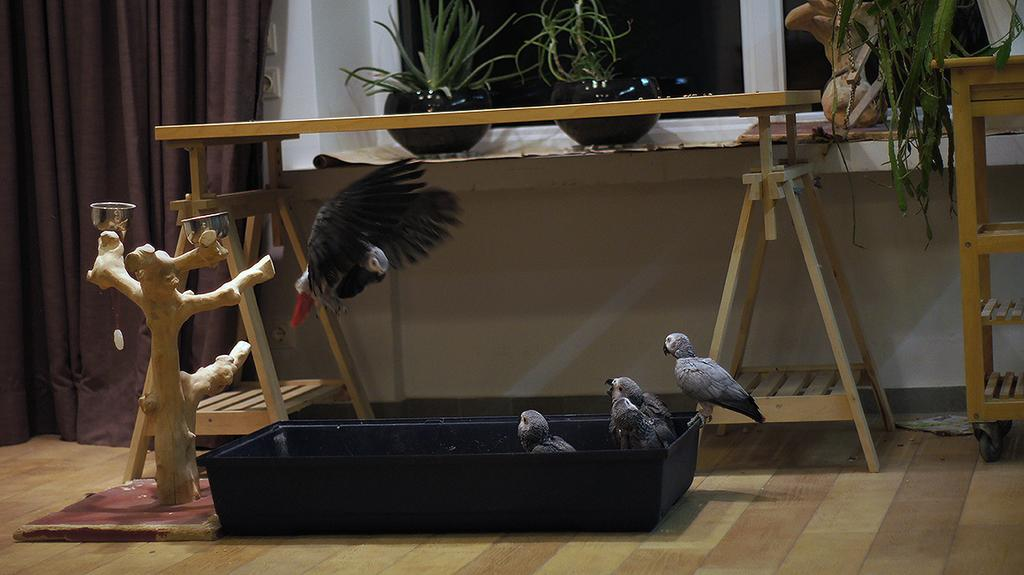What is the main subject of the image? The main subject of the image is a depiction of a tree trunk. What objects are present in the image besides the tree trunk? There are bowls, a black-colored object, birds, tables, plants, and a brown-colored curtain in the image. Can you describe the black-colored object in the image? Unfortunately, the facts provided do not give a detailed description of the black-colored object. What type of birds can be seen in the image? The facts provided do not specify the type of birds in the image. How many tables are visible in the image? The facts provided do not mention the number of tables in the image. What type of plants are present in the image? The facts provided do not specify the type of plants in the image. Where is the dad in the image? There is no mention of a dad or any person in the image. What type of parcel is being delivered in the image? There is no mention of a parcel or any delivery in the image. What is the stick used for in the image? There is no mention of a stick in the image. 